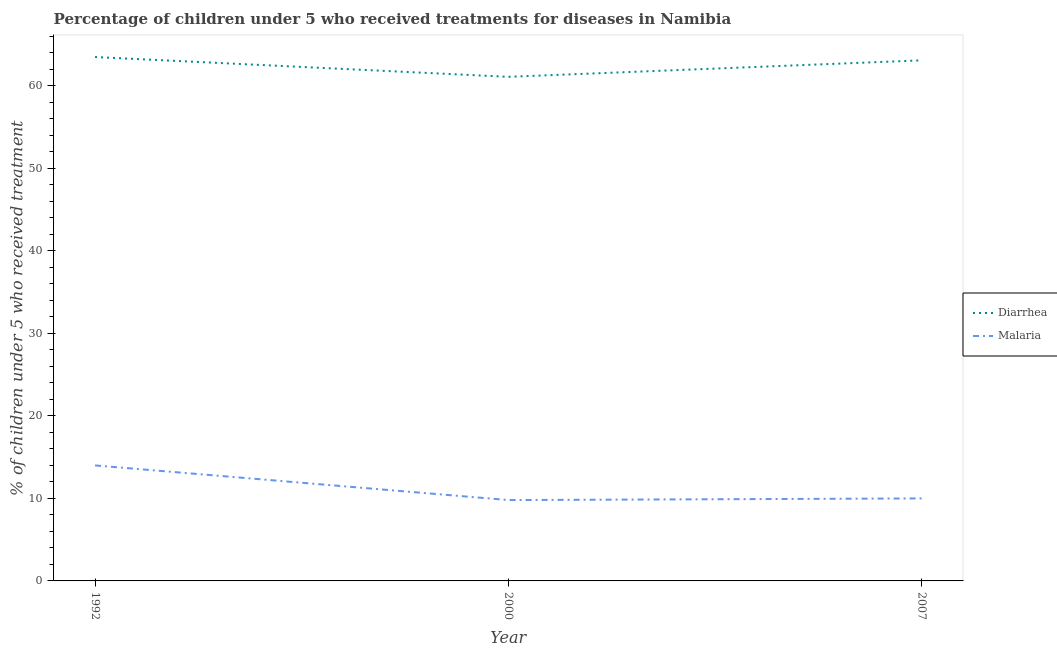How many different coloured lines are there?
Ensure brevity in your answer.  2. Is the number of lines equal to the number of legend labels?
Keep it short and to the point. Yes. What is the percentage of children who received treatment for diarrhoea in 2000?
Your answer should be very brief. 61.1. Across all years, what is the maximum percentage of children who received treatment for diarrhoea?
Your answer should be compact. 63.5. Across all years, what is the minimum percentage of children who received treatment for diarrhoea?
Offer a terse response. 61.1. In which year was the percentage of children who received treatment for diarrhoea minimum?
Ensure brevity in your answer.  2000. What is the total percentage of children who received treatment for malaria in the graph?
Your response must be concise. 33.8. What is the difference between the percentage of children who received treatment for diarrhoea in 1992 and the percentage of children who received treatment for malaria in 2000?
Your answer should be very brief. 53.7. What is the average percentage of children who received treatment for malaria per year?
Your answer should be very brief. 11.27. In the year 1992, what is the difference between the percentage of children who received treatment for malaria and percentage of children who received treatment for diarrhoea?
Your answer should be very brief. -49.5. In how many years, is the percentage of children who received treatment for malaria greater than 56 %?
Offer a terse response. 0. What is the ratio of the percentage of children who received treatment for malaria in 1992 to that in 2000?
Provide a short and direct response. 1.43. Is the percentage of children who received treatment for malaria in 1992 less than that in 2000?
Keep it short and to the point. No. Is the difference between the percentage of children who received treatment for malaria in 1992 and 2000 greater than the difference between the percentage of children who received treatment for diarrhoea in 1992 and 2000?
Your response must be concise. Yes. What is the difference between the highest and the second highest percentage of children who received treatment for diarrhoea?
Provide a short and direct response. 0.4. What is the difference between the highest and the lowest percentage of children who received treatment for diarrhoea?
Ensure brevity in your answer.  2.4. In how many years, is the percentage of children who received treatment for malaria greater than the average percentage of children who received treatment for malaria taken over all years?
Make the answer very short. 1. Does the percentage of children who received treatment for malaria monotonically increase over the years?
Your answer should be compact. No. Is the percentage of children who received treatment for malaria strictly greater than the percentage of children who received treatment for diarrhoea over the years?
Offer a terse response. No. What is the difference between two consecutive major ticks on the Y-axis?
Your response must be concise. 10. How many legend labels are there?
Offer a terse response. 2. How are the legend labels stacked?
Offer a terse response. Vertical. What is the title of the graph?
Ensure brevity in your answer.  Percentage of children under 5 who received treatments for diseases in Namibia. Does "Non-resident workers" appear as one of the legend labels in the graph?
Provide a short and direct response. No. What is the label or title of the Y-axis?
Offer a very short reply. % of children under 5 who received treatment. What is the % of children under 5 who received treatment of Diarrhea in 1992?
Provide a succinct answer. 63.5. What is the % of children under 5 who received treatment of Diarrhea in 2000?
Keep it short and to the point. 61.1. What is the % of children under 5 who received treatment of Malaria in 2000?
Ensure brevity in your answer.  9.8. What is the % of children under 5 who received treatment in Diarrhea in 2007?
Your response must be concise. 63.1. What is the % of children under 5 who received treatment of Malaria in 2007?
Your answer should be compact. 10. Across all years, what is the maximum % of children under 5 who received treatment of Diarrhea?
Provide a succinct answer. 63.5. Across all years, what is the minimum % of children under 5 who received treatment of Diarrhea?
Your answer should be very brief. 61.1. What is the total % of children under 5 who received treatment of Diarrhea in the graph?
Make the answer very short. 187.7. What is the total % of children under 5 who received treatment of Malaria in the graph?
Your response must be concise. 33.8. What is the difference between the % of children under 5 who received treatment in Diarrhea in 1992 and that in 2007?
Make the answer very short. 0.4. What is the difference between the % of children under 5 who received treatment in Malaria in 1992 and that in 2007?
Ensure brevity in your answer.  4. What is the difference between the % of children under 5 who received treatment of Diarrhea in 1992 and the % of children under 5 who received treatment of Malaria in 2000?
Your response must be concise. 53.7. What is the difference between the % of children under 5 who received treatment of Diarrhea in 1992 and the % of children under 5 who received treatment of Malaria in 2007?
Give a very brief answer. 53.5. What is the difference between the % of children under 5 who received treatment in Diarrhea in 2000 and the % of children under 5 who received treatment in Malaria in 2007?
Your response must be concise. 51.1. What is the average % of children under 5 who received treatment of Diarrhea per year?
Offer a terse response. 62.57. What is the average % of children under 5 who received treatment of Malaria per year?
Your response must be concise. 11.27. In the year 1992, what is the difference between the % of children under 5 who received treatment in Diarrhea and % of children under 5 who received treatment in Malaria?
Make the answer very short. 49.5. In the year 2000, what is the difference between the % of children under 5 who received treatment in Diarrhea and % of children under 5 who received treatment in Malaria?
Offer a very short reply. 51.3. In the year 2007, what is the difference between the % of children under 5 who received treatment of Diarrhea and % of children under 5 who received treatment of Malaria?
Offer a terse response. 53.1. What is the ratio of the % of children under 5 who received treatment of Diarrhea in 1992 to that in 2000?
Ensure brevity in your answer.  1.04. What is the ratio of the % of children under 5 who received treatment of Malaria in 1992 to that in 2000?
Your answer should be very brief. 1.43. What is the ratio of the % of children under 5 who received treatment of Malaria in 1992 to that in 2007?
Your answer should be very brief. 1.4. What is the ratio of the % of children under 5 who received treatment of Diarrhea in 2000 to that in 2007?
Make the answer very short. 0.97. What is the difference between the highest and the lowest % of children under 5 who received treatment in Diarrhea?
Offer a very short reply. 2.4. 